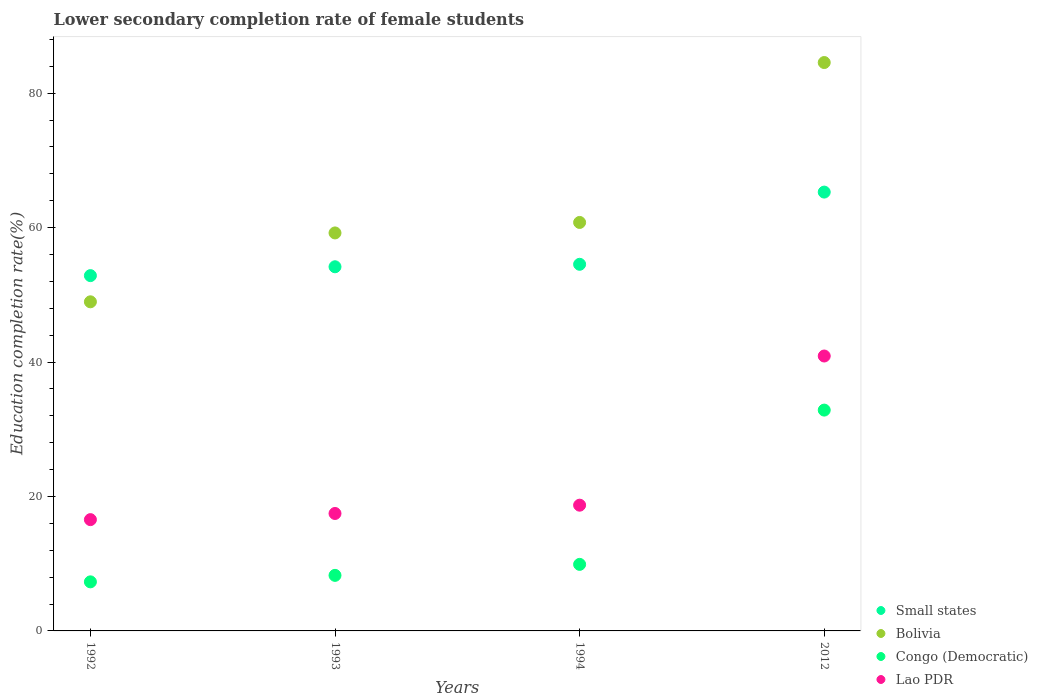What is the lower secondary completion rate of female students in Congo (Democratic) in 2012?
Offer a very short reply. 32.85. Across all years, what is the maximum lower secondary completion rate of female students in Lao PDR?
Provide a short and direct response. 40.89. Across all years, what is the minimum lower secondary completion rate of female students in Congo (Democratic)?
Provide a succinct answer. 7.3. In which year was the lower secondary completion rate of female students in Lao PDR maximum?
Provide a succinct answer. 2012. In which year was the lower secondary completion rate of female students in Bolivia minimum?
Your answer should be compact. 1992. What is the total lower secondary completion rate of female students in Small states in the graph?
Give a very brief answer. 226.84. What is the difference between the lower secondary completion rate of female students in Bolivia in 1993 and that in 1994?
Offer a very short reply. -1.56. What is the difference between the lower secondary completion rate of female students in Small states in 1992 and the lower secondary completion rate of female students in Lao PDR in 2012?
Provide a succinct answer. 11.96. What is the average lower secondary completion rate of female students in Small states per year?
Ensure brevity in your answer.  56.71. In the year 2012, what is the difference between the lower secondary completion rate of female students in Lao PDR and lower secondary completion rate of female students in Congo (Democratic)?
Ensure brevity in your answer.  8.05. What is the ratio of the lower secondary completion rate of female students in Lao PDR in 1993 to that in 2012?
Ensure brevity in your answer.  0.43. Is the lower secondary completion rate of female students in Congo (Democratic) in 1993 less than that in 2012?
Offer a terse response. Yes. Is the difference between the lower secondary completion rate of female students in Lao PDR in 1992 and 1993 greater than the difference between the lower secondary completion rate of female students in Congo (Democratic) in 1992 and 1993?
Offer a terse response. Yes. What is the difference between the highest and the second highest lower secondary completion rate of female students in Bolivia?
Give a very brief answer. 23.79. What is the difference between the highest and the lowest lower secondary completion rate of female students in Lao PDR?
Ensure brevity in your answer.  24.34. In how many years, is the lower secondary completion rate of female students in Lao PDR greater than the average lower secondary completion rate of female students in Lao PDR taken over all years?
Make the answer very short. 1. Is the sum of the lower secondary completion rate of female students in Lao PDR in 1992 and 2012 greater than the maximum lower secondary completion rate of female students in Bolivia across all years?
Make the answer very short. No. Is it the case that in every year, the sum of the lower secondary completion rate of female students in Lao PDR and lower secondary completion rate of female students in Congo (Democratic)  is greater than the sum of lower secondary completion rate of female students in Bolivia and lower secondary completion rate of female students in Small states?
Keep it short and to the point. Yes. Is it the case that in every year, the sum of the lower secondary completion rate of female students in Congo (Democratic) and lower secondary completion rate of female students in Small states  is greater than the lower secondary completion rate of female students in Bolivia?
Offer a terse response. Yes. Does the lower secondary completion rate of female students in Lao PDR monotonically increase over the years?
Give a very brief answer. Yes. Is the lower secondary completion rate of female students in Small states strictly greater than the lower secondary completion rate of female students in Congo (Democratic) over the years?
Your answer should be compact. Yes. Is the lower secondary completion rate of female students in Small states strictly less than the lower secondary completion rate of female students in Bolivia over the years?
Ensure brevity in your answer.  No. Does the graph contain any zero values?
Offer a very short reply. No. Where does the legend appear in the graph?
Your answer should be compact. Bottom right. How many legend labels are there?
Offer a very short reply. 4. What is the title of the graph?
Make the answer very short. Lower secondary completion rate of female students. What is the label or title of the Y-axis?
Make the answer very short. Education completion rate(%). What is the Education completion rate(%) in Small states in 1992?
Keep it short and to the point. 52.85. What is the Education completion rate(%) of Bolivia in 1992?
Your response must be concise. 48.96. What is the Education completion rate(%) of Congo (Democratic) in 1992?
Provide a succinct answer. 7.3. What is the Education completion rate(%) of Lao PDR in 1992?
Offer a terse response. 16.55. What is the Education completion rate(%) of Small states in 1993?
Offer a very short reply. 54.17. What is the Education completion rate(%) of Bolivia in 1993?
Your answer should be very brief. 59.2. What is the Education completion rate(%) of Congo (Democratic) in 1993?
Ensure brevity in your answer.  8.26. What is the Education completion rate(%) of Lao PDR in 1993?
Offer a terse response. 17.47. What is the Education completion rate(%) of Small states in 1994?
Make the answer very short. 54.54. What is the Education completion rate(%) of Bolivia in 1994?
Keep it short and to the point. 60.76. What is the Education completion rate(%) in Congo (Democratic) in 1994?
Your answer should be compact. 9.9. What is the Education completion rate(%) of Lao PDR in 1994?
Ensure brevity in your answer.  18.7. What is the Education completion rate(%) of Small states in 2012?
Your answer should be compact. 65.28. What is the Education completion rate(%) in Bolivia in 2012?
Keep it short and to the point. 84.55. What is the Education completion rate(%) in Congo (Democratic) in 2012?
Give a very brief answer. 32.85. What is the Education completion rate(%) of Lao PDR in 2012?
Offer a very short reply. 40.89. Across all years, what is the maximum Education completion rate(%) in Small states?
Offer a very short reply. 65.28. Across all years, what is the maximum Education completion rate(%) of Bolivia?
Your answer should be compact. 84.55. Across all years, what is the maximum Education completion rate(%) in Congo (Democratic)?
Offer a very short reply. 32.85. Across all years, what is the maximum Education completion rate(%) of Lao PDR?
Keep it short and to the point. 40.89. Across all years, what is the minimum Education completion rate(%) of Small states?
Your answer should be very brief. 52.85. Across all years, what is the minimum Education completion rate(%) of Bolivia?
Offer a terse response. 48.96. Across all years, what is the minimum Education completion rate(%) in Congo (Democratic)?
Ensure brevity in your answer.  7.3. Across all years, what is the minimum Education completion rate(%) of Lao PDR?
Your answer should be very brief. 16.55. What is the total Education completion rate(%) of Small states in the graph?
Your answer should be compact. 226.84. What is the total Education completion rate(%) in Bolivia in the graph?
Offer a terse response. 253.47. What is the total Education completion rate(%) of Congo (Democratic) in the graph?
Your answer should be very brief. 58.31. What is the total Education completion rate(%) of Lao PDR in the graph?
Offer a terse response. 93.62. What is the difference between the Education completion rate(%) in Small states in 1992 and that in 1993?
Offer a very short reply. -1.32. What is the difference between the Education completion rate(%) in Bolivia in 1992 and that in 1993?
Your response must be concise. -10.25. What is the difference between the Education completion rate(%) in Congo (Democratic) in 1992 and that in 1993?
Ensure brevity in your answer.  -0.96. What is the difference between the Education completion rate(%) of Lao PDR in 1992 and that in 1993?
Keep it short and to the point. -0.92. What is the difference between the Education completion rate(%) of Small states in 1992 and that in 1994?
Keep it short and to the point. -1.68. What is the difference between the Education completion rate(%) in Bolivia in 1992 and that in 1994?
Your answer should be very brief. -11.81. What is the difference between the Education completion rate(%) of Congo (Democratic) in 1992 and that in 1994?
Your answer should be very brief. -2.6. What is the difference between the Education completion rate(%) in Lao PDR in 1992 and that in 1994?
Your answer should be compact. -2.15. What is the difference between the Education completion rate(%) in Small states in 1992 and that in 2012?
Make the answer very short. -12.43. What is the difference between the Education completion rate(%) of Bolivia in 1992 and that in 2012?
Your answer should be very brief. -35.59. What is the difference between the Education completion rate(%) of Congo (Democratic) in 1992 and that in 2012?
Make the answer very short. -25.55. What is the difference between the Education completion rate(%) of Lao PDR in 1992 and that in 2012?
Your answer should be compact. -24.34. What is the difference between the Education completion rate(%) in Small states in 1993 and that in 1994?
Give a very brief answer. -0.37. What is the difference between the Education completion rate(%) of Bolivia in 1993 and that in 1994?
Keep it short and to the point. -1.56. What is the difference between the Education completion rate(%) of Congo (Democratic) in 1993 and that in 1994?
Provide a succinct answer. -1.64. What is the difference between the Education completion rate(%) in Lao PDR in 1993 and that in 1994?
Your answer should be compact. -1.23. What is the difference between the Education completion rate(%) of Small states in 1993 and that in 2012?
Offer a very short reply. -11.11. What is the difference between the Education completion rate(%) in Bolivia in 1993 and that in 2012?
Your response must be concise. -25.35. What is the difference between the Education completion rate(%) of Congo (Democratic) in 1993 and that in 2012?
Provide a succinct answer. -24.59. What is the difference between the Education completion rate(%) of Lao PDR in 1993 and that in 2012?
Your answer should be compact. -23.42. What is the difference between the Education completion rate(%) in Small states in 1994 and that in 2012?
Keep it short and to the point. -10.74. What is the difference between the Education completion rate(%) in Bolivia in 1994 and that in 2012?
Offer a very short reply. -23.79. What is the difference between the Education completion rate(%) of Congo (Democratic) in 1994 and that in 2012?
Offer a very short reply. -22.95. What is the difference between the Education completion rate(%) in Lao PDR in 1994 and that in 2012?
Your answer should be very brief. -22.19. What is the difference between the Education completion rate(%) of Small states in 1992 and the Education completion rate(%) of Bolivia in 1993?
Offer a very short reply. -6.35. What is the difference between the Education completion rate(%) in Small states in 1992 and the Education completion rate(%) in Congo (Democratic) in 1993?
Ensure brevity in your answer.  44.59. What is the difference between the Education completion rate(%) of Small states in 1992 and the Education completion rate(%) of Lao PDR in 1993?
Make the answer very short. 35.38. What is the difference between the Education completion rate(%) in Bolivia in 1992 and the Education completion rate(%) in Congo (Democratic) in 1993?
Your answer should be very brief. 40.69. What is the difference between the Education completion rate(%) of Bolivia in 1992 and the Education completion rate(%) of Lao PDR in 1993?
Keep it short and to the point. 31.49. What is the difference between the Education completion rate(%) of Congo (Democratic) in 1992 and the Education completion rate(%) of Lao PDR in 1993?
Keep it short and to the point. -10.17. What is the difference between the Education completion rate(%) of Small states in 1992 and the Education completion rate(%) of Bolivia in 1994?
Ensure brevity in your answer.  -7.91. What is the difference between the Education completion rate(%) of Small states in 1992 and the Education completion rate(%) of Congo (Democratic) in 1994?
Provide a short and direct response. 42.95. What is the difference between the Education completion rate(%) in Small states in 1992 and the Education completion rate(%) in Lao PDR in 1994?
Offer a terse response. 34.15. What is the difference between the Education completion rate(%) in Bolivia in 1992 and the Education completion rate(%) in Congo (Democratic) in 1994?
Your response must be concise. 39.06. What is the difference between the Education completion rate(%) in Bolivia in 1992 and the Education completion rate(%) in Lao PDR in 1994?
Make the answer very short. 30.25. What is the difference between the Education completion rate(%) in Congo (Democratic) in 1992 and the Education completion rate(%) in Lao PDR in 1994?
Provide a succinct answer. -11.41. What is the difference between the Education completion rate(%) in Small states in 1992 and the Education completion rate(%) in Bolivia in 2012?
Your answer should be very brief. -31.7. What is the difference between the Education completion rate(%) in Small states in 1992 and the Education completion rate(%) in Congo (Democratic) in 2012?
Provide a short and direct response. 20. What is the difference between the Education completion rate(%) in Small states in 1992 and the Education completion rate(%) in Lao PDR in 2012?
Keep it short and to the point. 11.96. What is the difference between the Education completion rate(%) in Bolivia in 1992 and the Education completion rate(%) in Congo (Democratic) in 2012?
Provide a succinct answer. 16.11. What is the difference between the Education completion rate(%) of Bolivia in 1992 and the Education completion rate(%) of Lao PDR in 2012?
Give a very brief answer. 8.06. What is the difference between the Education completion rate(%) of Congo (Democratic) in 1992 and the Education completion rate(%) of Lao PDR in 2012?
Ensure brevity in your answer.  -33.6. What is the difference between the Education completion rate(%) in Small states in 1993 and the Education completion rate(%) in Bolivia in 1994?
Your answer should be very brief. -6.59. What is the difference between the Education completion rate(%) of Small states in 1993 and the Education completion rate(%) of Congo (Democratic) in 1994?
Provide a short and direct response. 44.27. What is the difference between the Education completion rate(%) in Small states in 1993 and the Education completion rate(%) in Lao PDR in 1994?
Keep it short and to the point. 35.46. What is the difference between the Education completion rate(%) in Bolivia in 1993 and the Education completion rate(%) in Congo (Democratic) in 1994?
Offer a very short reply. 49.3. What is the difference between the Education completion rate(%) in Bolivia in 1993 and the Education completion rate(%) in Lao PDR in 1994?
Ensure brevity in your answer.  40.5. What is the difference between the Education completion rate(%) in Congo (Democratic) in 1993 and the Education completion rate(%) in Lao PDR in 1994?
Offer a very short reply. -10.44. What is the difference between the Education completion rate(%) of Small states in 1993 and the Education completion rate(%) of Bolivia in 2012?
Your answer should be compact. -30.38. What is the difference between the Education completion rate(%) of Small states in 1993 and the Education completion rate(%) of Congo (Democratic) in 2012?
Keep it short and to the point. 21.32. What is the difference between the Education completion rate(%) in Small states in 1993 and the Education completion rate(%) in Lao PDR in 2012?
Offer a very short reply. 13.27. What is the difference between the Education completion rate(%) in Bolivia in 1993 and the Education completion rate(%) in Congo (Democratic) in 2012?
Ensure brevity in your answer.  26.35. What is the difference between the Education completion rate(%) in Bolivia in 1993 and the Education completion rate(%) in Lao PDR in 2012?
Give a very brief answer. 18.31. What is the difference between the Education completion rate(%) in Congo (Democratic) in 1993 and the Education completion rate(%) in Lao PDR in 2012?
Provide a short and direct response. -32.63. What is the difference between the Education completion rate(%) in Small states in 1994 and the Education completion rate(%) in Bolivia in 2012?
Your answer should be very brief. -30.01. What is the difference between the Education completion rate(%) in Small states in 1994 and the Education completion rate(%) in Congo (Democratic) in 2012?
Offer a terse response. 21.69. What is the difference between the Education completion rate(%) in Small states in 1994 and the Education completion rate(%) in Lao PDR in 2012?
Offer a very short reply. 13.64. What is the difference between the Education completion rate(%) in Bolivia in 1994 and the Education completion rate(%) in Congo (Democratic) in 2012?
Offer a very short reply. 27.91. What is the difference between the Education completion rate(%) in Bolivia in 1994 and the Education completion rate(%) in Lao PDR in 2012?
Your response must be concise. 19.87. What is the difference between the Education completion rate(%) in Congo (Democratic) in 1994 and the Education completion rate(%) in Lao PDR in 2012?
Provide a short and direct response. -31. What is the average Education completion rate(%) in Small states per year?
Provide a short and direct response. 56.71. What is the average Education completion rate(%) of Bolivia per year?
Offer a very short reply. 63.37. What is the average Education completion rate(%) in Congo (Democratic) per year?
Give a very brief answer. 14.58. What is the average Education completion rate(%) of Lao PDR per year?
Offer a very short reply. 23.41. In the year 1992, what is the difference between the Education completion rate(%) in Small states and Education completion rate(%) in Bolivia?
Make the answer very short. 3.9. In the year 1992, what is the difference between the Education completion rate(%) of Small states and Education completion rate(%) of Congo (Democratic)?
Give a very brief answer. 45.55. In the year 1992, what is the difference between the Education completion rate(%) of Small states and Education completion rate(%) of Lao PDR?
Your answer should be compact. 36.3. In the year 1992, what is the difference between the Education completion rate(%) of Bolivia and Education completion rate(%) of Congo (Democratic)?
Offer a very short reply. 41.66. In the year 1992, what is the difference between the Education completion rate(%) in Bolivia and Education completion rate(%) in Lao PDR?
Make the answer very short. 32.4. In the year 1992, what is the difference between the Education completion rate(%) in Congo (Democratic) and Education completion rate(%) in Lao PDR?
Provide a short and direct response. -9.26. In the year 1993, what is the difference between the Education completion rate(%) of Small states and Education completion rate(%) of Bolivia?
Offer a very short reply. -5.03. In the year 1993, what is the difference between the Education completion rate(%) of Small states and Education completion rate(%) of Congo (Democratic)?
Provide a succinct answer. 45.91. In the year 1993, what is the difference between the Education completion rate(%) in Small states and Education completion rate(%) in Lao PDR?
Your answer should be compact. 36.7. In the year 1993, what is the difference between the Education completion rate(%) of Bolivia and Education completion rate(%) of Congo (Democratic)?
Offer a terse response. 50.94. In the year 1993, what is the difference between the Education completion rate(%) of Bolivia and Education completion rate(%) of Lao PDR?
Provide a succinct answer. 41.73. In the year 1993, what is the difference between the Education completion rate(%) in Congo (Democratic) and Education completion rate(%) in Lao PDR?
Offer a terse response. -9.21. In the year 1994, what is the difference between the Education completion rate(%) in Small states and Education completion rate(%) in Bolivia?
Provide a short and direct response. -6.23. In the year 1994, what is the difference between the Education completion rate(%) in Small states and Education completion rate(%) in Congo (Democratic)?
Your answer should be very brief. 44.64. In the year 1994, what is the difference between the Education completion rate(%) of Small states and Education completion rate(%) of Lao PDR?
Give a very brief answer. 35.83. In the year 1994, what is the difference between the Education completion rate(%) in Bolivia and Education completion rate(%) in Congo (Democratic)?
Your answer should be very brief. 50.86. In the year 1994, what is the difference between the Education completion rate(%) in Bolivia and Education completion rate(%) in Lao PDR?
Provide a short and direct response. 42.06. In the year 1994, what is the difference between the Education completion rate(%) of Congo (Democratic) and Education completion rate(%) of Lao PDR?
Provide a short and direct response. -8.81. In the year 2012, what is the difference between the Education completion rate(%) in Small states and Education completion rate(%) in Bolivia?
Offer a very short reply. -19.27. In the year 2012, what is the difference between the Education completion rate(%) of Small states and Education completion rate(%) of Congo (Democratic)?
Your answer should be very brief. 32.43. In the year 2012, what is the difference between the Education completion rate(%) in Small states and Education completion rate(%) in Lao PDR?
Make the answer very short. 24.38. In the year 2012, what is the difference between the Education completion rate(%) of Bolivia and Education completion rate(%) of Congo (Democratic)?
Give a very brief answer. 51.7. In the year 2012, what is the difference between the Education completion rate(%) of Bolivia and Education completion rate(%) of Lao PDR?
Make the answer very short. 43.66. In the year 2012, what is the difference between the Education completion rate(%) in Congo (Democratic) and Education completion rate(%) in Lao PDR?
Offer a very short reply. -8.05. What is the ratio of the Education completion rate(%) in Small states in 1992 to that in 1993?
Your answer should be compact. 0.98. What is the ratio of the Education completion rate(%) in Bolivia in 1992 to that in 1993?
Give a very brief answer. 0.83. What is the ratio of the Education completion rate(%) of Congo (Democratic) in 1992 to that in 1993?
Provide a short and direct response. 0.88. What is the ratio of the Education completion rate(%) in Lao PDR in 1992 to that in 1993?
Keep it short and to the point. 0.95. What is the ratio of the Education completion rate(%) in Small states in 1992 to that in 1994?
Provide a succinct answer. 0.97. What is the ratio of the Education completion rate(%) of Bolivia in 1992 to that in 1994?
Provide a short and direct response. 0.81. What is the ratio of the Education completion rate(%) of Congo (Democratic) in 1992 to that in 1994?
Give a very brief answer. 0.74. What is the ratio of the Education completion rate(%) in Lao PDR in 1992 to that in 1994?
Keep it short and to the point. 0.89. What is the ratio of the Education completion rate(%) in Small states in 1992 to that in 2012?
Keep it short and to the point. 0.81. What is the ratio of the Education completion rate(%) of Bolivia in 1992 to that in 2012?
Your answer should be compact. 0.58. What is the ratio of the Education completion rate(%) of Congo (Democratic) in 1992 to that in 2012?
Keep it short and to the point. 0.22. What is the ratio of the Education completion rate(%) in Lao PDR in 1992 to that in 2012?
Keep it short and to the point. 0.4. What is the ratio of the Education completion rate(%) of Small states in 1993 to that in 1994?
Offer a terse response. 0.99. What is the ratio of the Education completion rate(%) in Bolivia in 1993 to that in 1994?
Keep it short and to the point. 0.97. What is the ratio of the Education completion rate(%) of Congo (Democratic) in 1993 to that in 1994?
Provide a short and direct response. 0.83. What is the ratio of the Education completion rate(%) in Lao PDR in 1993 to that in 1994?
Your response must be concise. 0.93. What is the ratio of the Education completion rate(%) in Small states in 1993 to that in 2012?
Make the answer very short. 0.83. What is the ratio of the Education completion rate(%) in Bolivia in 1993 to that in 2012?
Provide a succinct answer. 0.7. What is the ratio of the Education completion rate(%) in Congo (Democratic) in 1993 to that in 2012?
Your answer should be very brief. 0.25. What is the ratio of the Education completion rate(%) in Lao PDR in 1993 to that in 2012?
Your answer should be compact. 0.43. What is the ratio of the Education completion rate(%) of Small states in 1994 to that in 2012?
Your answer should be very brief. 0.84. What is the ratio of the Education completion rate(%) in Bolivia in 1994 to that in 2012?
Offer a terse response. 0.72. What is the ratio of the Education completion rate(%) of Congo (Democratic) in 1994 to that in 2012?
Provide a succinct answer. 0.3. What is the ratio of the Education completion rate(%) in Lao PDR in 1994 to that in 2012?
Your answer should be compact. 0.46. What is the difference between the highest and the second highest Education completion rate(%) of Small states?
Keep it short and to the point. 10.74. What is the difference between the highest and the second highest Education completion rate(%) of Bolivia?
Provide a short and direct response. 23.79. What is the difference between the highest and the second highest Education completion rate(%) of Congo (Democratic)?
Provide a succinct answer. 22.95. What is the difference between the highest and the second highest Education completion rate(%) of Lao PDR?
Your response must be concise. 22.19. What is the difference between the highest and the lowest Education completion rate(%) in Small states?
Your response must be concise. 12.43. What is the difference between the highest and the lowest Education completion rate(%) of Bolivia?
Ensure brevity in your answer.  35.59. What is the difference between the highest and the lowest Education completion rate(%) of Congo (Democratic)?
Your answer should be very brief. 25.55. What is the difference between the highest and the lowest Education completion rate(%) in Lao PDR?
Give a very brief answer. 24.34. 